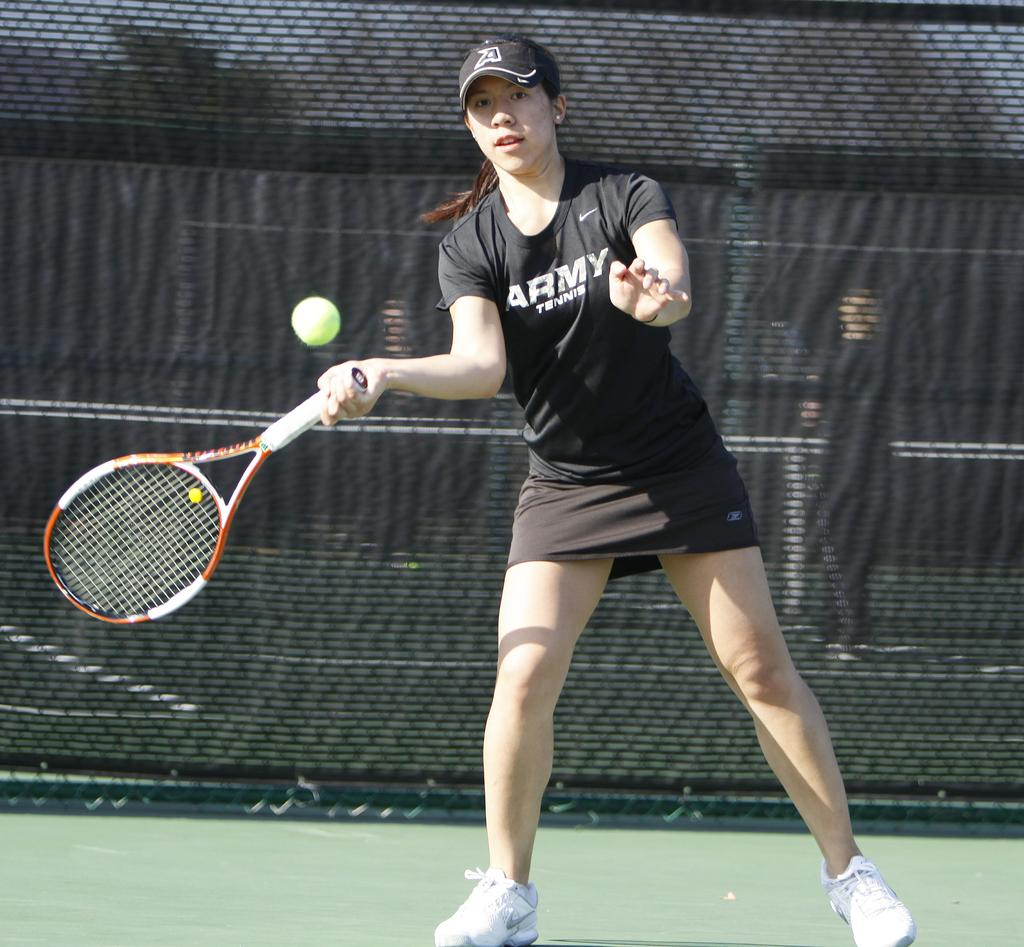What is the woman in the image doing? The woman is standing and playing tennis in the image. What object does the woman have in her hand? The woman has a bat (racket) in her hand. What is the woman looking at? The woman is looking at the ball. What can be seen in the background of the image? There is a net in the background of the image. What type of surface is visible in the image? There is ground visible in the image. What type of operation is the woman performing on her nails in the image? There is no indication of any operation or activity related to nails in the image; the woman is playing tennis. 